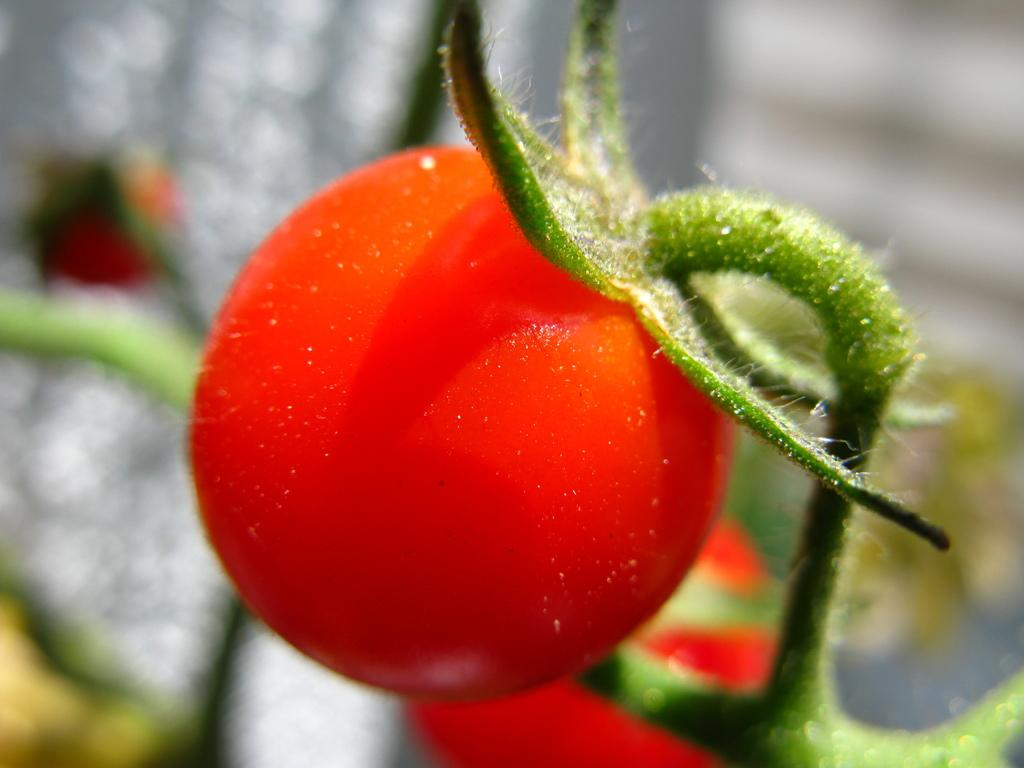What type of food can be seen in the image? There are vegetables in the image. What type of desk is visible in the image? There is no desk present in the image; it only features vegetables. Is there a print of a painting visible in the image? There is no print or painting present in the image; it only features vegetables. 